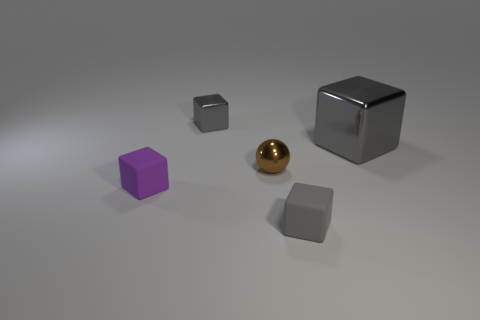Is the number of tiny metallic things in front of the small purple block less than the number of big gray objects behind the large metallic block?
Offer a very short reply. No. Are there any other things that have the same shape as the large metal thing?
Ensure brevity in your answer.  Yes. What is the material of the big thing that is the same color as the tiny metal cube?
Provide a succinct answer. Metal. What number of gray metal things are behind the gray metal thing that is behind the large gray metallic object that is behind the brown sphere?
Offer a very short reply. 0. What number of brown balls are behind the tiny metallic block?
Provide a succinct answer. 0. What number of brown objects have the same material as the small sphere?
Provide a succinct answer. 0. What is the color of the small sphere that is made of the same material as the big gray block?
Make the answer very short. Brown. What is the cube right of the tiny cube on the right side of the tiny gray object that is behind the big gray object made of?
Provide a short and direct response. Metal. There is a purple cube that is left of the metallic sphere; is it the same size as the tiny gray matte object?
Provide a short and direct response. Yes. How many tiny things are either gray cubes or brown metallic spheres?
Provide a short and direct response. 3. 